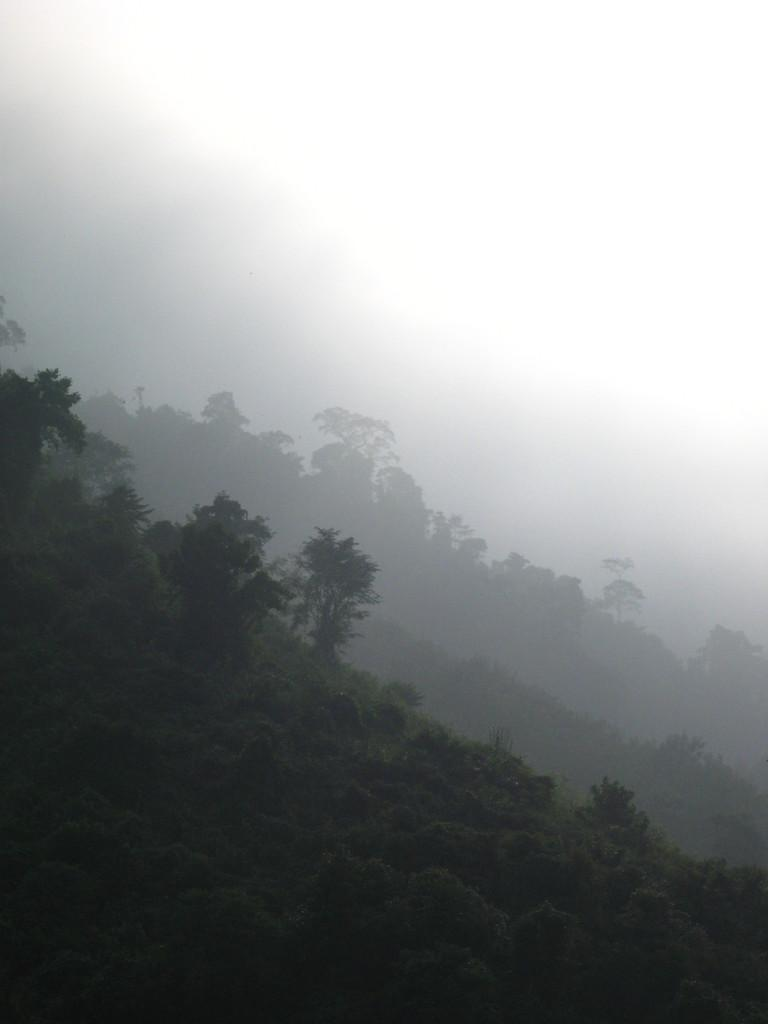What type of vegetation can be seen in the image? There are trees, bushes, and plants in the image. What is on the ground in the image? There is grass on the ground in the image. What is visible at the top of the image? The sky is visible at the top of the image. What can be seen in the background of the image? There appears to be smoke in the background of the image. What is the name of the person standing on the grass in the image? There is no person standing on the grass in the image. How many feet tall is the tallest tree in the image? There is no information provided about the height of the trees in the image. 